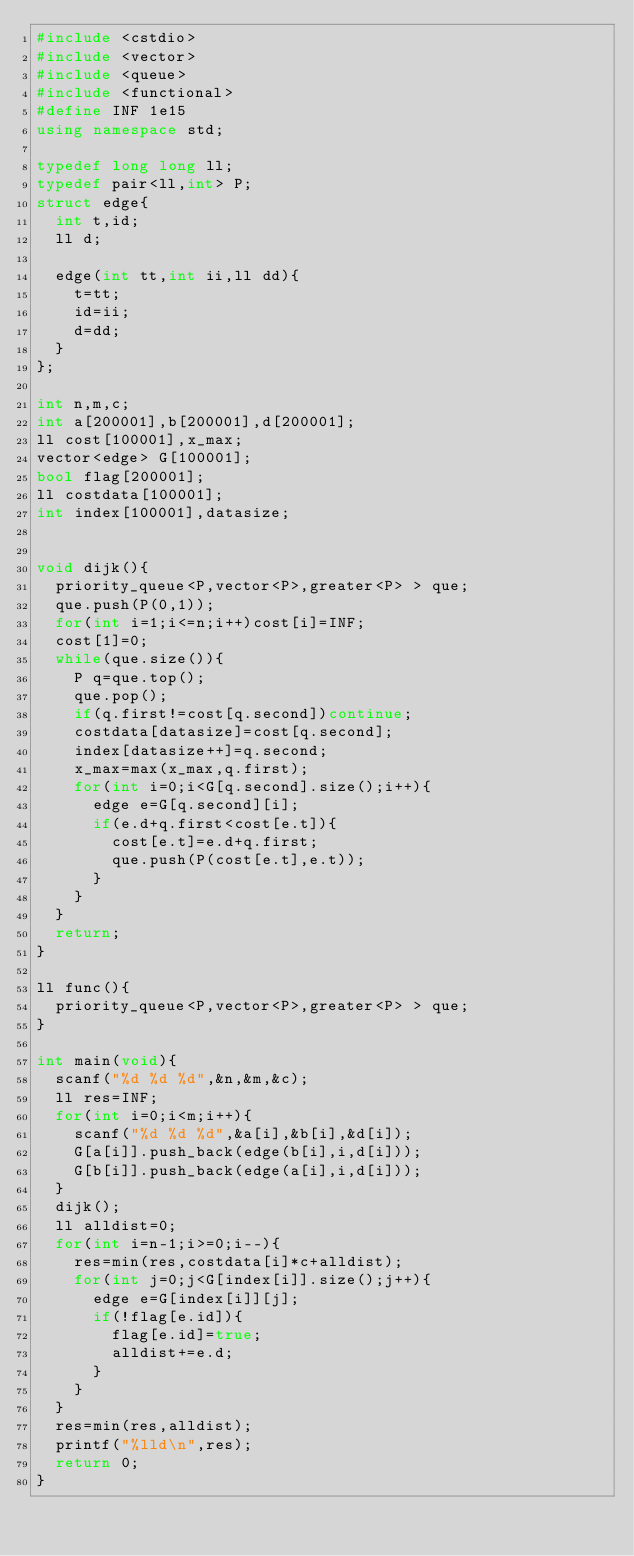Convert code to text. <code><loc_0><loc_0><loc_500><loc_500><_C++_>#include <cstdio>
#include <vector>
#include <queue>
#include <functional>
#define INF 1e15
using namespace std;

typedef long long ll;
typedef pair<ll,int> P;
struct edge{
	int t,id;
	ll d;

	edge(int tt,int ii,ll dd){
		t=tt;
		id=ii;
		d=dd;
	}
};

int n,m,c;
int a[200001],b[200001],d[200001];
ll cost[100001],x_max;
vector<edge> G[100001];
bool flag[200001];
ll costdata[100001];
int index[100001],datasize;


void dijk(){
	priority_queue<P,vector<P>,greater<P> > que;
	que.push(P(0,1));
	for(int i=1;i<=n;i++)cost[i]=INF;
	cost[1]=0;
	while(que.size()){
		P q=que.top();
		que.pop();
		if(q.first!=cost[q.second])continue;
		costdata[datasize]=cost[q.second];
		index[datasize++]=q.second;
		x_max=max(x_max,q.first);
		for(int i=0;i<G[q.second].size();i++){
			edge e=G[q.second][i];
			if(e.d+q.first<cost[e.t]){
				cost[e.t]=e.d+q.first;
				que.push(P(cost[e.t],e.t));
			}
		}
	}
	return;
}

ll func(){
	priority_queue<P,vector<P>,greater<P> > que;
}

int main(void){
	scanf("%d %d %d",&n,&m,&c);
	ll res=INF;
	for(int i=0;i<m;i++){
		scanf("%d %d %d",&a[i],&b[i],&d[i]);
		G[a[i]].push_back(edge(b[i],i,d[i]));
		G[b[i]].push_back(edge(a[i],i,d[i]));
	}
	dijk();
	ll alldist=0;
	for(int i=n-1;i>=0;i--){
		res=min(res,costdata[i]*c+alldist);
		for(int j=0;j<G[index[i]].size();j++){
			edge e=G[index[i]][j];
			if(!flag[e.id]){
				flag[e.id]=true;
				alldist+=e.d;
			}
		}
	}
	res=min(res,alldist);
	printf("%lld\n",res);
	return 0;
}</code> 